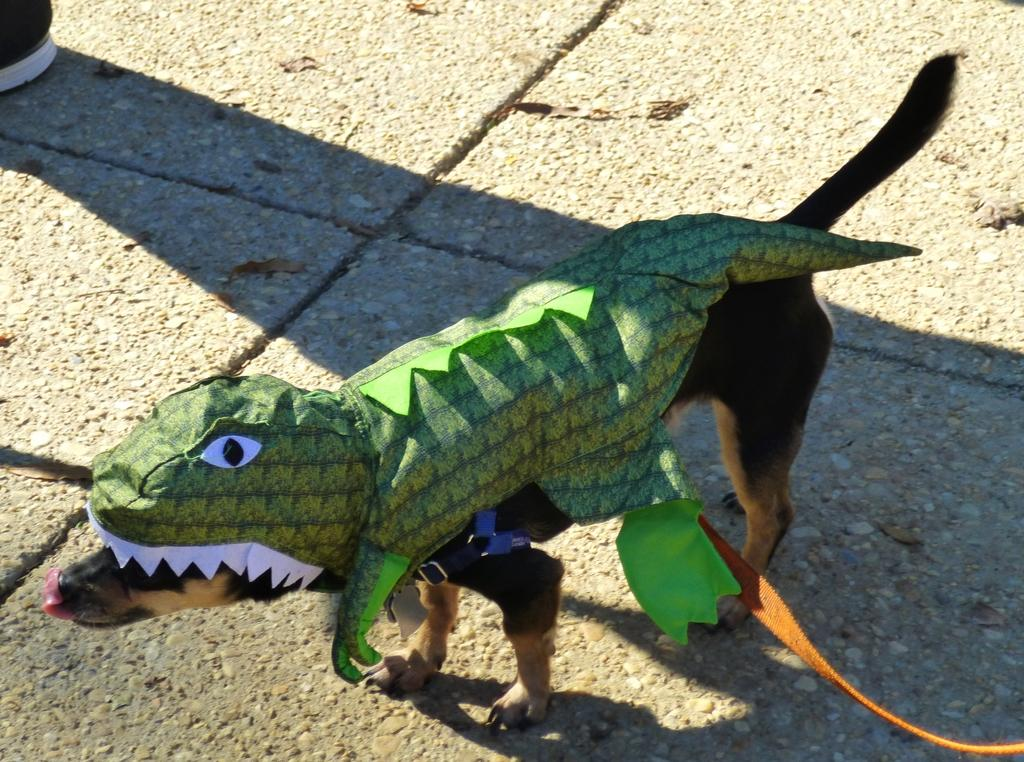What type of animal is in the image? There is a dog in the image. Can you describe the dog's coloring? The dog has black and brown coloring. What is on the dog in the image? There is a green color toy on the dog. What shape is the basin that the dog is wearing in the image? There is no basin present in the image, and the dog is not wearing any shape. What type of watch is the dog holding in the image? There is no watch present in the image, and the dog is not holding anything. 